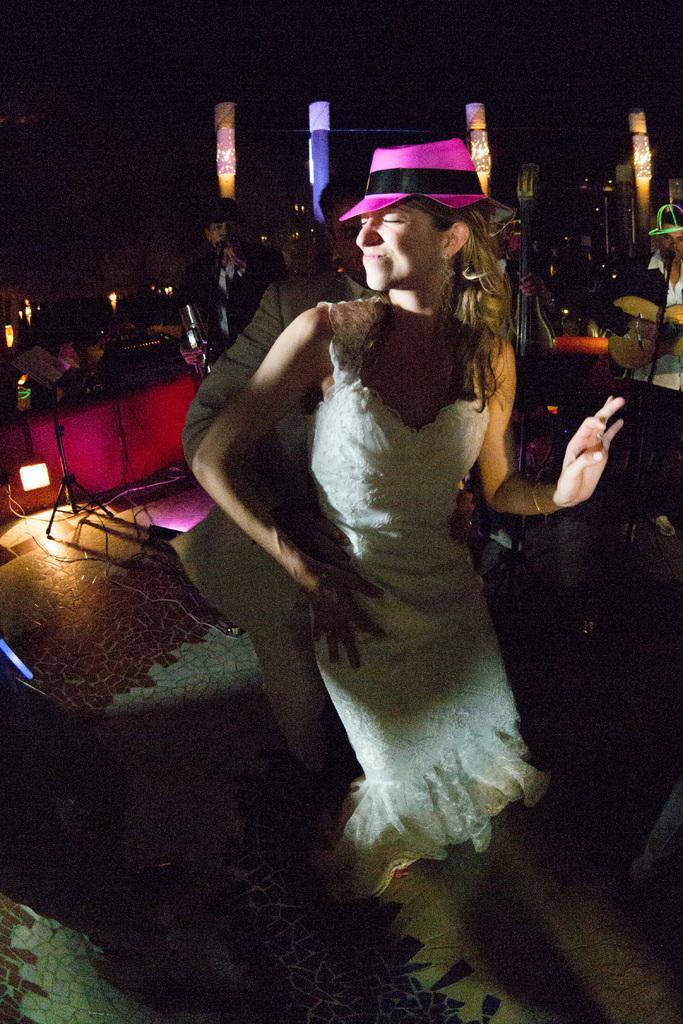In one or two sentences, can you explain what this image depicts? In this picture we can see a man and a woman are dancing in the front, in the background there are some people playing musical instruments, on the left side we can see a light, a tripod and wires, in the background there are some lights, we can see a dark background. 